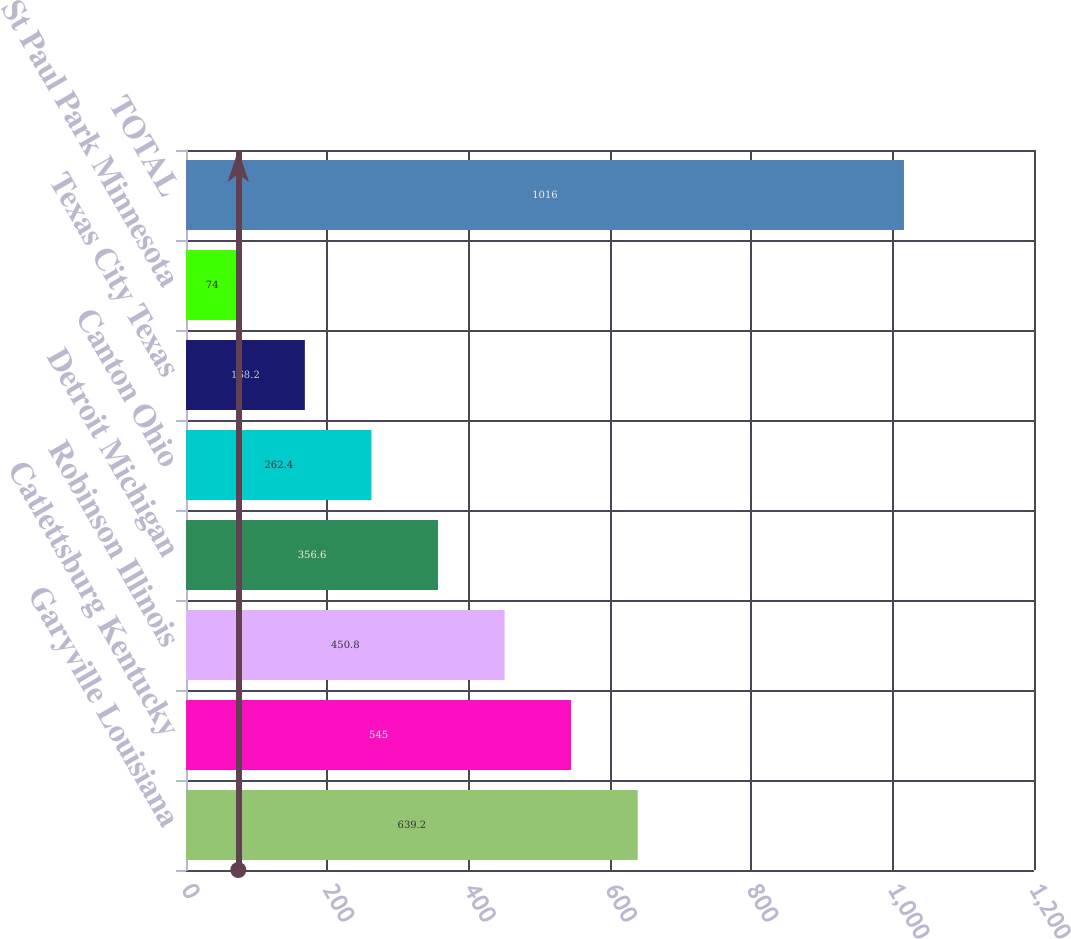<chart> <loc_0><loc_0><loc_500><loc_500><bar_chart><fcel>Garyville Louisiana<fcel>Catlettsburg Kentucky<fcel>Robinson Illinois<fcel>Detroit Michigan<fcel>Canton Ohio<fcel>Texas City Texas<fcel>St Paul Park Minnesota<fcel>TOTAL<nl><fcel>639.2<fcel>545<fcel>450.8<fcel>356.6<fcel>262.4<fcel>168.2<fcel>74<fcel>1016<nl></chart> 